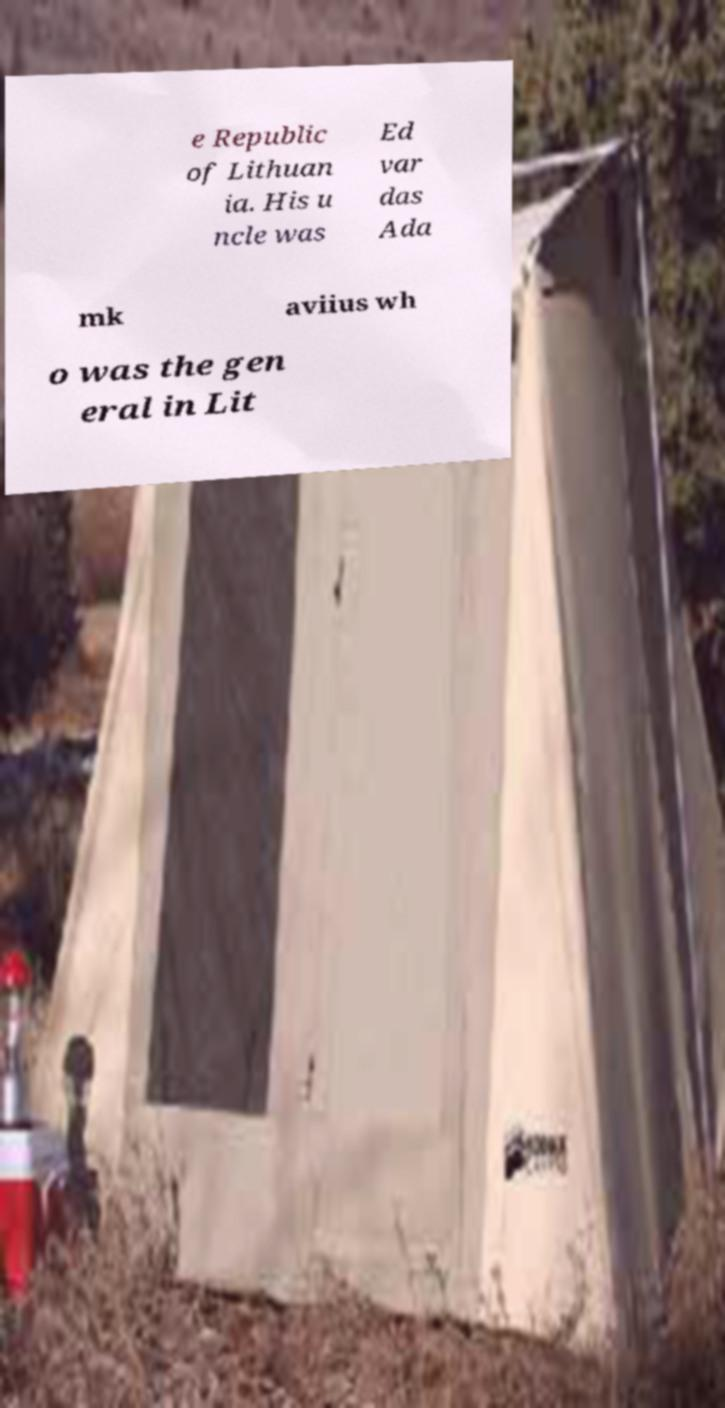Can you read and provide the text displayed in the image?This photo seems to have some interesting text. Can you extract and type it out for me? e Republic of Lithuan ia. His u ncle was Ed var das Ada mk aviius wh o was the gen eral in Lit 